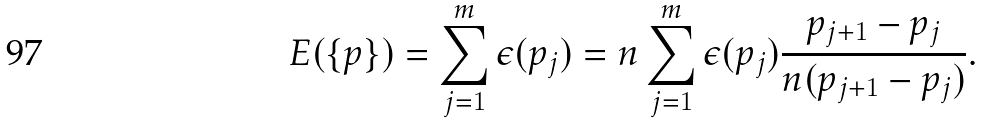Convert formula to latex. <formula><loc_0><loc_0><loc_500><loc_500>E ( \{ p \} ) = \sum _ { j = 1 } ^ { m } \epsilon ( p _ { j } ) = n \sum _ { j = 1 } ^ { m } \epsilon ( p _ { j } ) \frac { p _ { j + 1 } - p _ { j } } { n ( p _ { j + 1 } - p _ { j } ) } .</formula> 